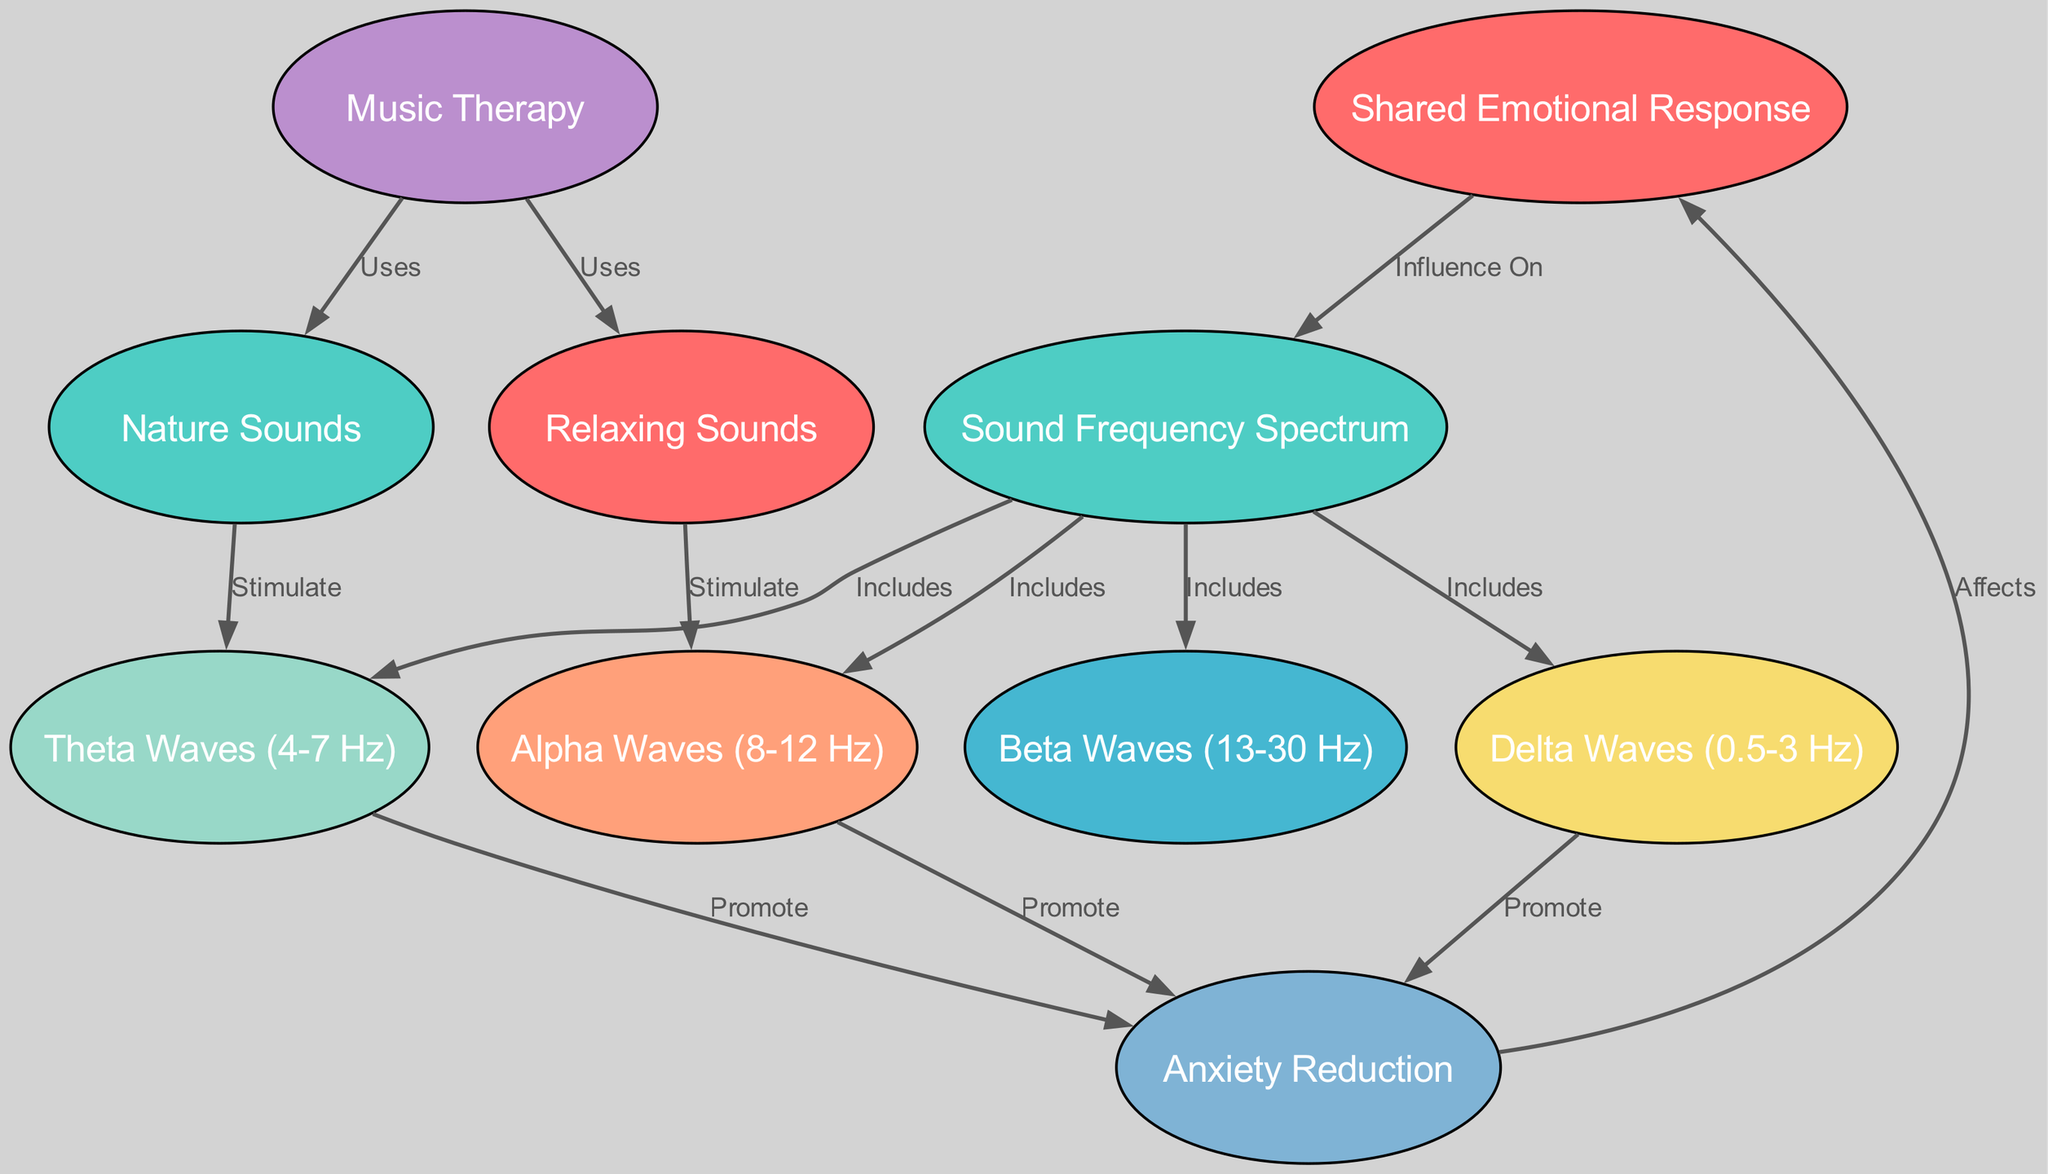What is the node that represents a Shared Emotional Response? The diagram includes a node labeled "Shared Emotional Response" which stands as a central theme connecting various aspects of sound frequencies and their influence.
Answer: Shared Emotional Response How many types of waves are included in the sound frequency spectrum? The diagram shows four specific types of waves: beta waves, alpha waves, theta waves, and delta waves. Thus, counting these gives us four distinct types of waves included in the sound frequency spectrum.
Answer: Four Which sound type stimulates alpha waves? The diagram indicates a direct relationship where "Relaxing Sounds" are stated to stimulate alpha waves; this arises from the use of relaxing sounds in music therapy.
Answer: Relaxing Sounds What effect do alpha, theta, and delta waves collectively promote? According to the diagram, all three wave types (alpha, theta, delta) promote "Anxiety Reduction," indicating their role in easing anxiety.
Answer: Anxiety Reduction What do nature sounds stimulate according to the diagram? The diagram explicitly mentions that "Nature Sounds" stimulate theta waves, creating a connection between nature sounds and this specific brain wave frequency.
Answer: Theta Waves How does anxiety reduction affect patient emotions? The diagram specifies that anxiety reduction has a direct effect on patient emotions, thus establishing a connection between reduced anxiety levels and improved emotional states.
Answer: Affects Which two sound types are mentioned as part of music therapy? The diagram indicates that music therapy uses both "Relaxing Sounds" and "Nature Sounds," providing two distinct categories of sound used for therapeutic purposes.
Answer: Relaxing Sounds and Nature Sounds What is the frequency range for delta waves? The delta waves represented in the diagram have a frequency range of 0.5 to 3 Hz, indicating their position in the overall frequency spectrum.
Answer: 0.5-3 Hz Which two frequencies included in the spectrum are most associated with relaxation? The diagram associates alpha waves and theta waves as the frequencies most directly connected to anxiety reduction and by extension, relaxation.
Answer: Alpha Waves and Theta Waves 